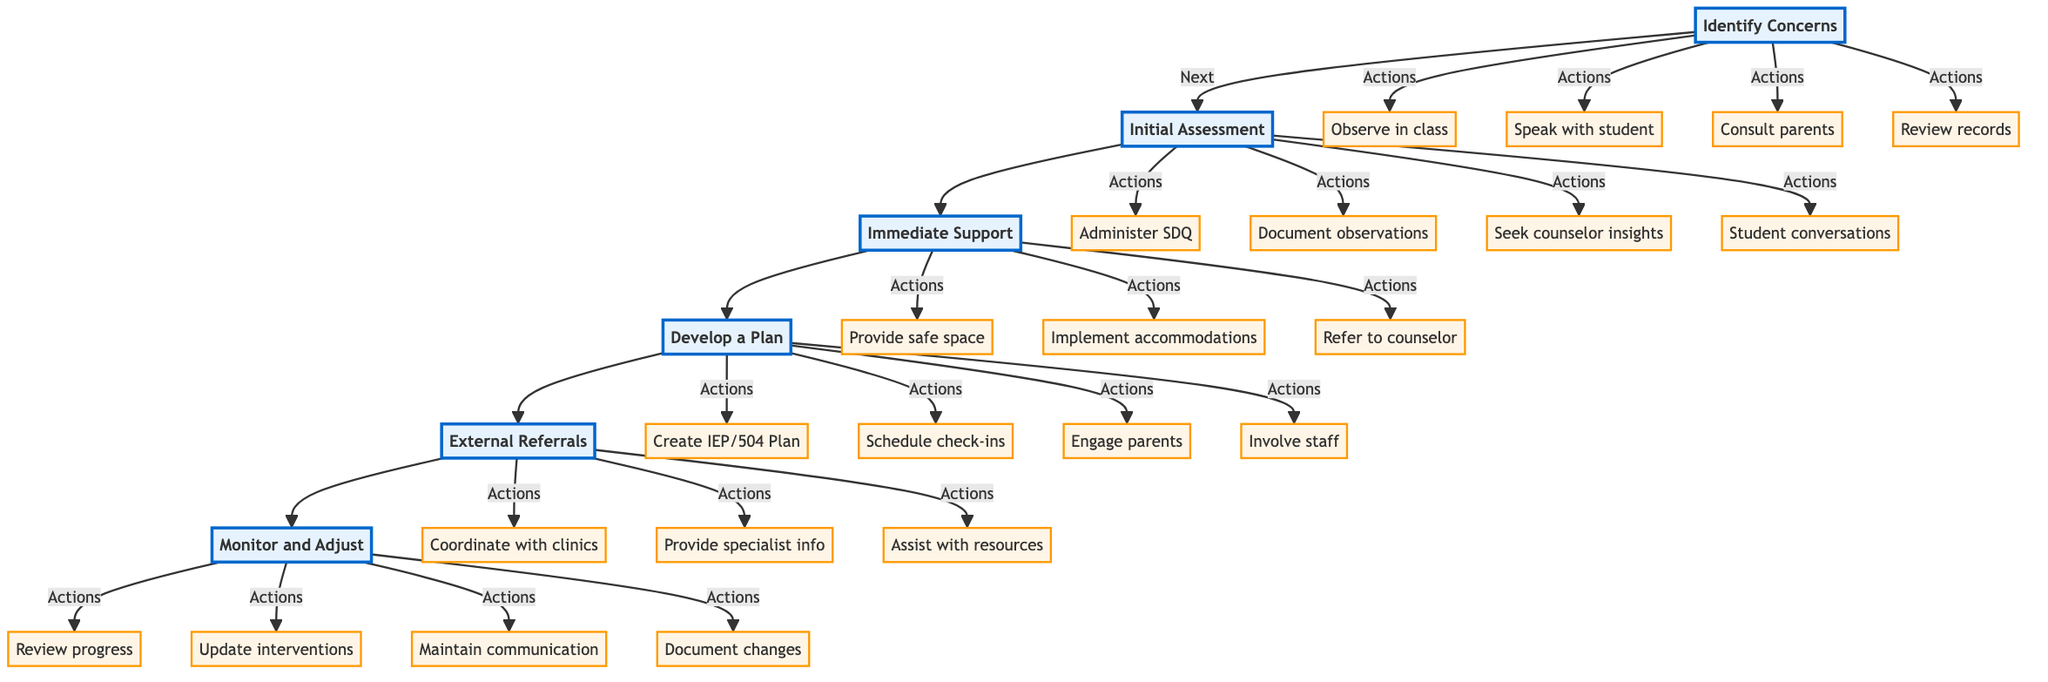What is the first step in the clinical pathway? The first step is indicated at the top of the diagram and is labeled as "Identify Concerns."
Answer: Identify Concerns How many main steps are in the clinical pathway? By counting the main labeled steps in the diagram, there are six distinct steps listed.
Answer: 6 What action is associated with "Immediate Support"? The diagram shows three actions linked to "Immediate Support," the first of which is "Provide a safe space."
Answer: Provide a safe space What step follows "Initial Assessment"? Looking at the flow from "Initial Assessment," the next step in the sequence is "Immediate Support."
Answer: Immediate Support How are the "Develop a Plan" and "External Referrals" connected? There is a directed flow from "Develop a Plan" leading directly to "External Referrals," showing the sequence of steps in the pathway.
Answer: Directly connected Which action involves family engagement during the plan development? The action "Engage parents or guardians in the process" is directly linked to the step of "Develop a Plan," highlighting family involvement.
Answer: Engage parents or guardians in the process What does "Monitor and Adjust" emphasize in the context of student support? In the diagram, "Monitor and Adjust" emphasizes the ongoing process of reviewing progress and making necessary changes to support the student.
Answer: Ongoing process of reviewing and adjusting Which step includes the use of a questionnaire for assessment? The "Initial Assessment" step specifically includes administering the "Strengths and Difficulties Questionnaire (SDQ)" as an action.
Answer: Initial Assessment What is the last step in the clinical pathway? The final step, at the bottom of the diagram, is labeled "Monitor and Adjust," indicating it is the concluding action in the pathway process.
Answer: Monitor and Adjust 